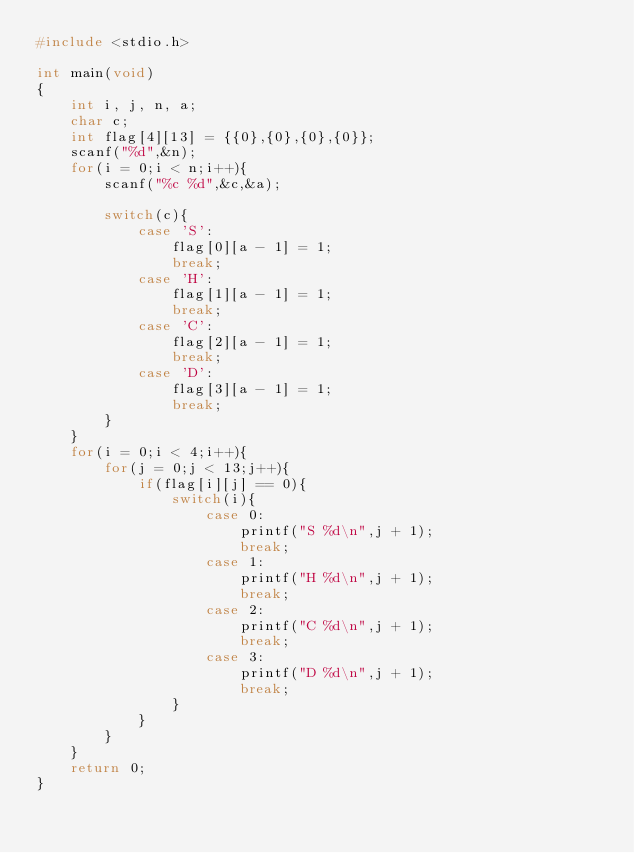Convert code to text. <code><loc_0><loc_0><loc_500><loc_500><_C_>#include <stdio.h>

int main(void)
{
	int i, j, n, a;
	char c;
	int flag[4][13] = {{0},{0},{0},{0}};
	scanf("%d",&n);
	for(i = 0;i < n;i++){
		scanf("%c %d",&c,&a);
		
		switch(c){
			case 'S':
				flag[0][a - 1] = 1;
				break;
			case 'H':
				flag[1][a - 1] = 1;
				break;
			case 'C':
				flag[2][a - 1] = 1;
				break;
			case 'D':
				flag[3][a - 1] = 1;
				break;
		}
	}
	for(i = 0;i < 4;i++){
		for(j = 0;j < 13;j++){
			if(flag[i][j] == 0){
				switch(i){
					case 0:
						printf("S %d\n",j + 1);
						break;
					case 1:
						printf("H %d\n",j + 1);
						break;
					case 2:
						printf("C %d\n",j + 1);
						break;
					case 3:
						printf("D %d\n",j + 1);
						break;
				}
			}
		}
	}
	return 0;
}</code> 